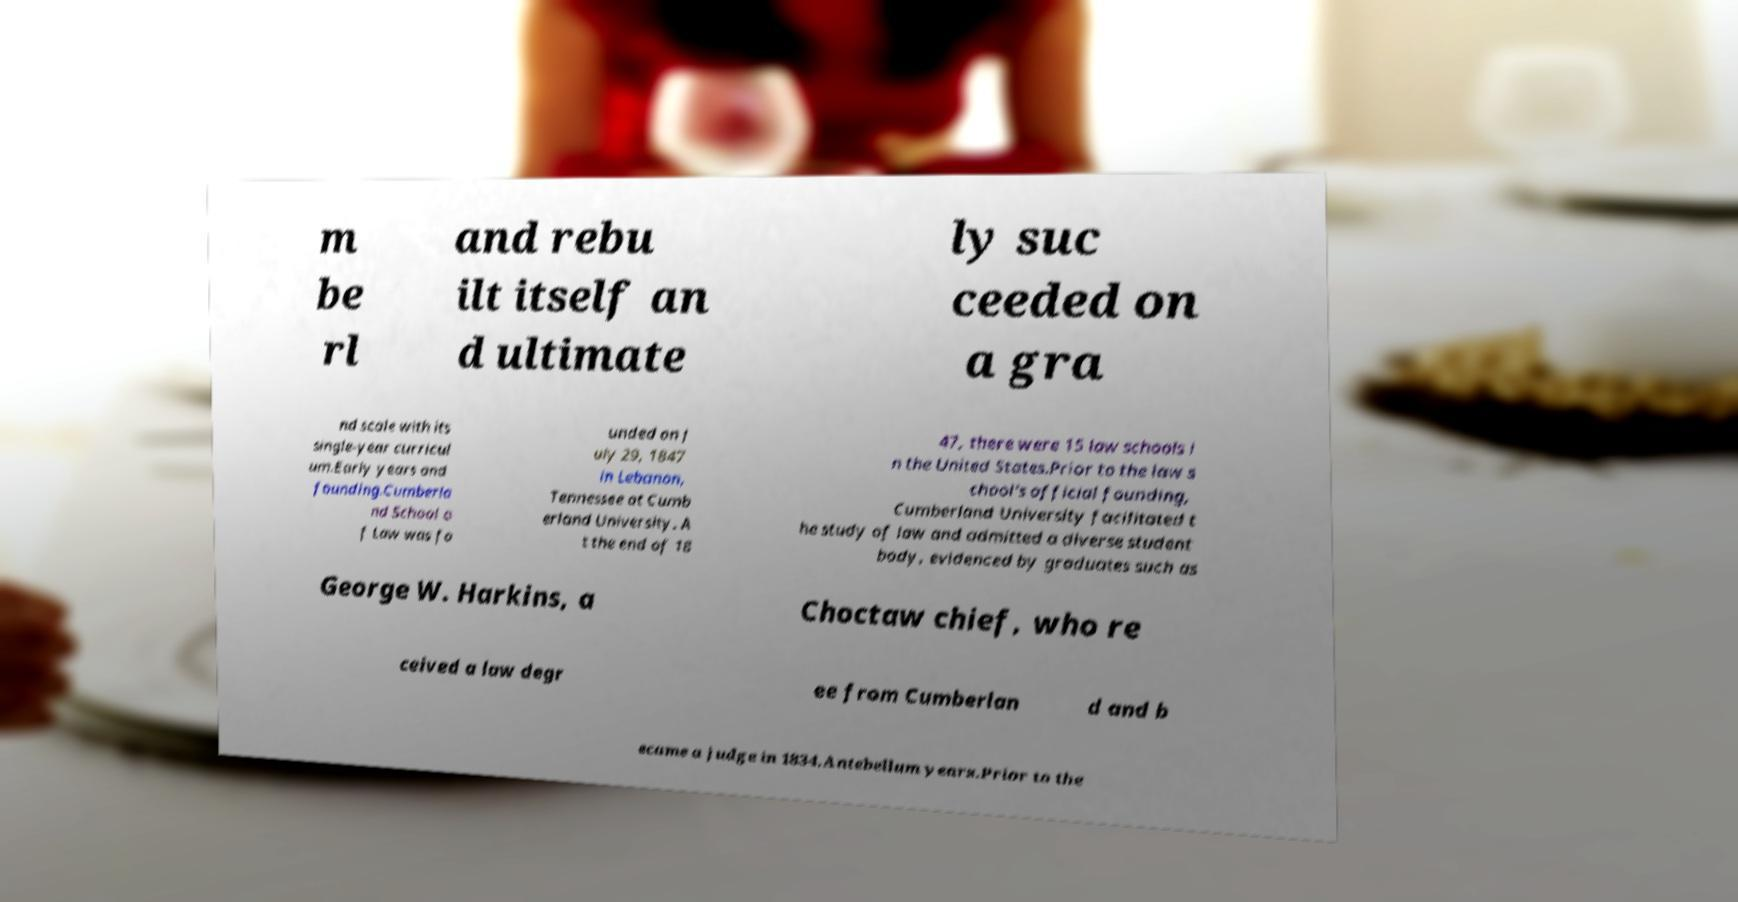What messages or text are displayed in this image? I need them in a readable, typed format. m be rl and rebu ilt itself an d ultimate ly suc ceeded on a gra nd scale with its single-year curricul um.Early years and founding.Cumberla nd School o f Law was fo unded on J uly 29, 1847 in Lebanon, Tennessee at Cumb erland University. A t the end of 18 47, there were 15 law schools i n the United States.Prior to the law s chool's official founding, Cumberland University facilitated t he study of law and admitted a diverse student body, evidenced by graduates such as George W. Harkins, a Choctaw chief, who re ceived a law degr ee from Cumberlan d and b ecame a judge in 1834.Antebellum years.Prior to the 